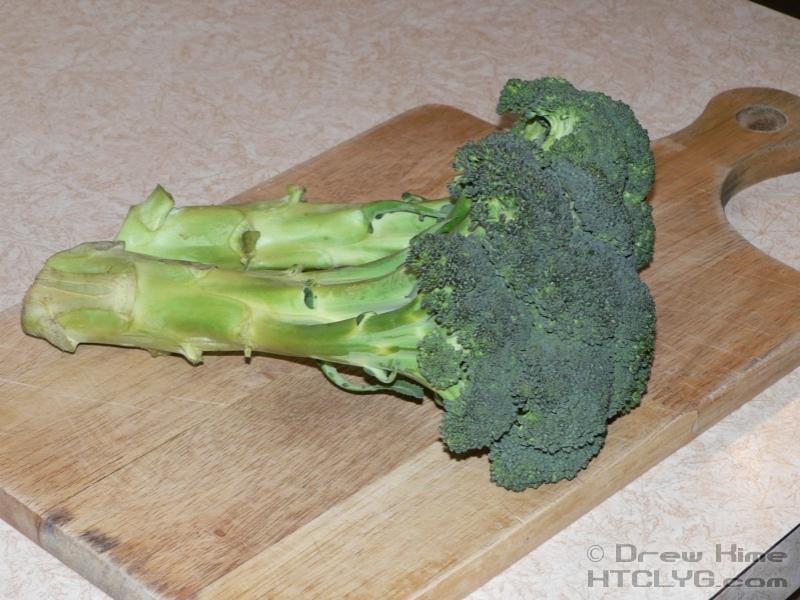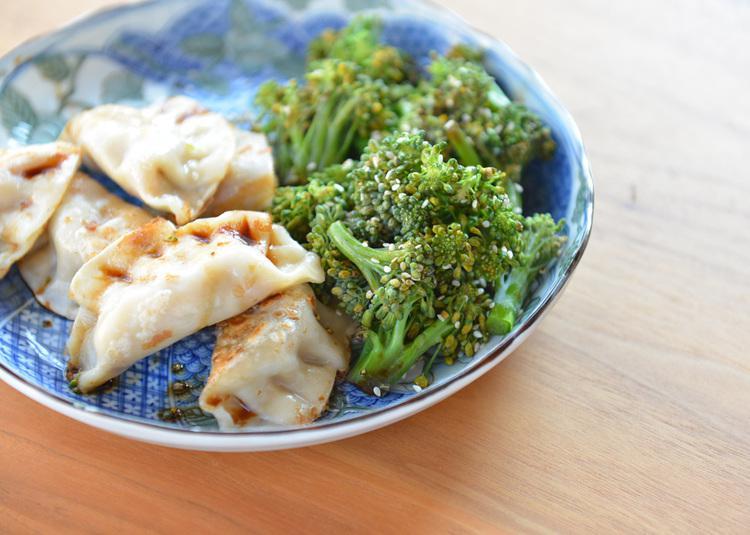The first image is the image on the left, the second image is the image on the right. Evaluate the accuracy of this statement regarding the images: "there are 3 bunches of broccoli against a white background". Is it true? Answer yes or no. No. The first image is the image on the left, the second image is the image on the right. Evaluate the accuracy of this statement regarding the images: "All images are on a plain white background.". Is it true? Answer yes or no. No. 